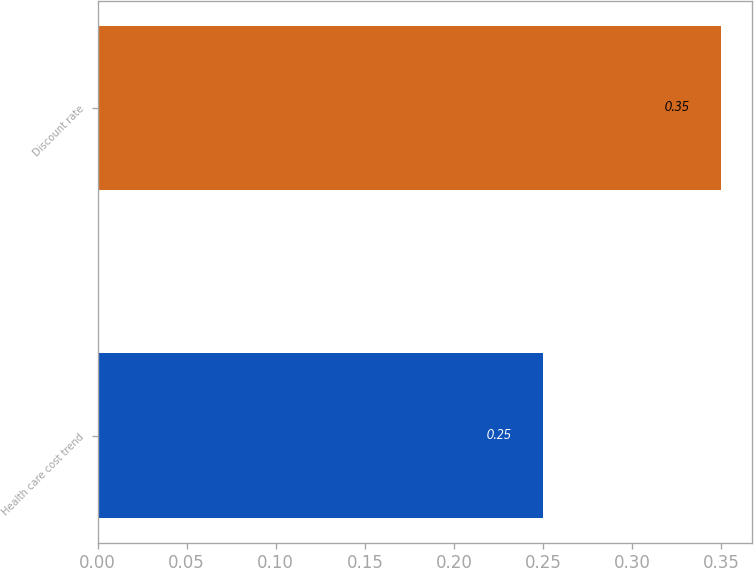<chart> <loc_0><loc_0><loc_500><loc_500><bar_chart><fcel>Health care cost trend<fcel>Discount rate<nl><fcel>0.25<fcel>0.35<nl></chart> 